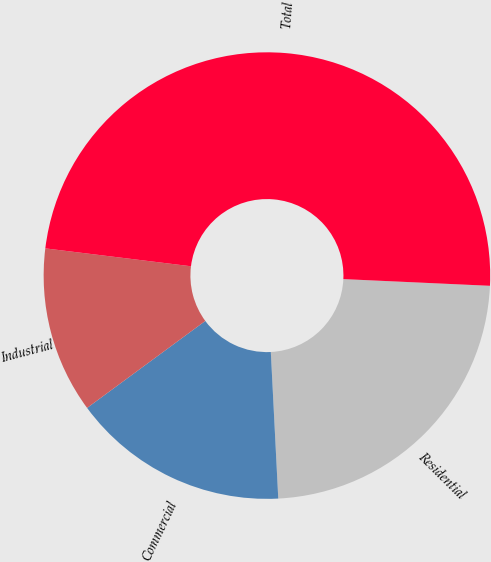Convert chart to OTSL. <chart><loc_0><loc_0><loc_500><loc_500><pie_chart><fcel>Residential<fcel>Commercial<fcel>Industrial<fcel>Total<nl><fcel>23.46%<fcel>15.71%<fcel>12.04%<fcel>48.78%<nl></chart> 